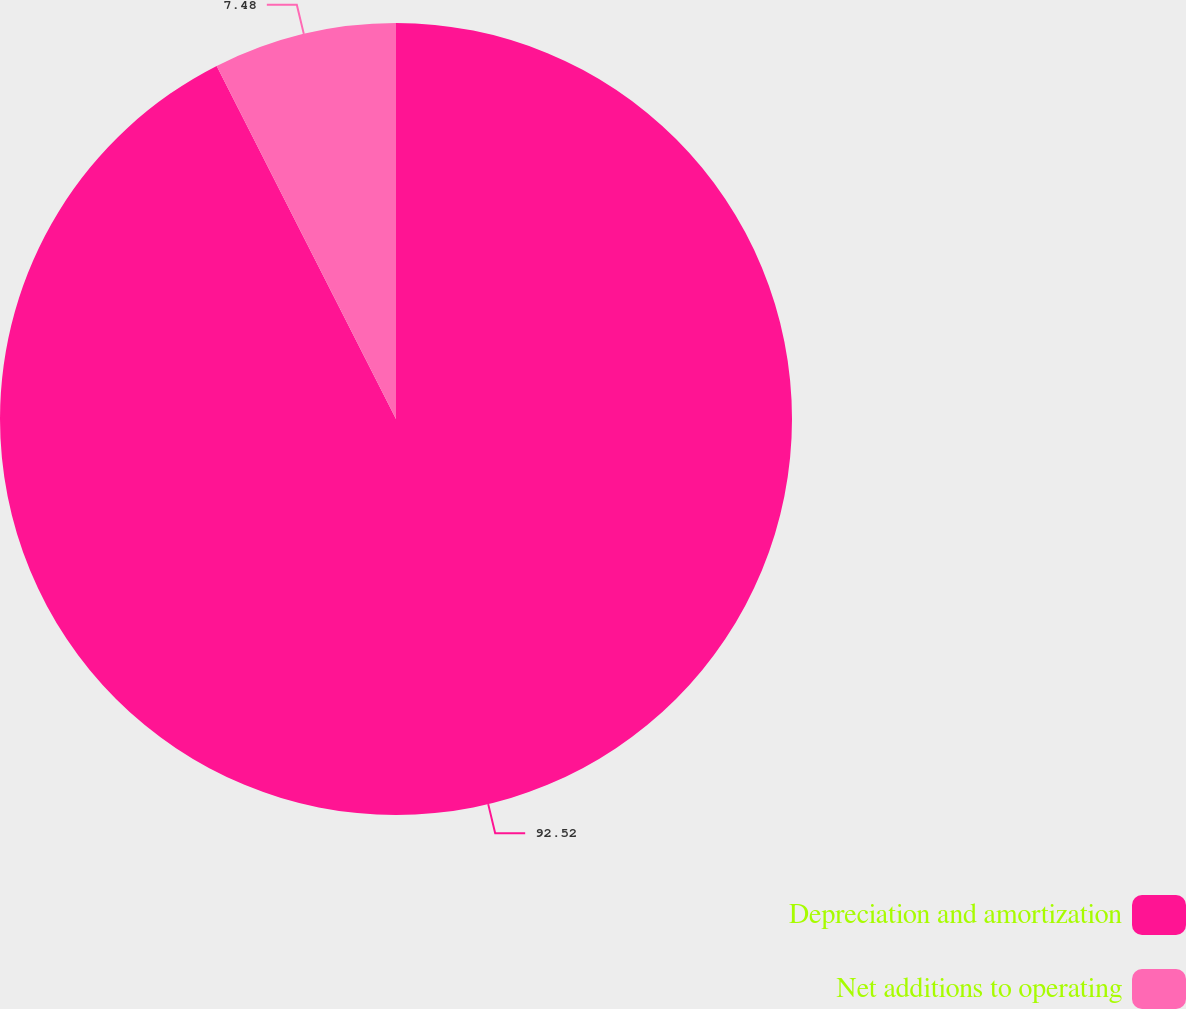Convert chart to OTSL. <chart><loc_0><loc_0><loc_500><loc_500><pie_chart><fcel>Depreciation and amortization<fcel>Net additions to operating<nl><fcel>92.52%<fcel>7.48%<nl></chart> 